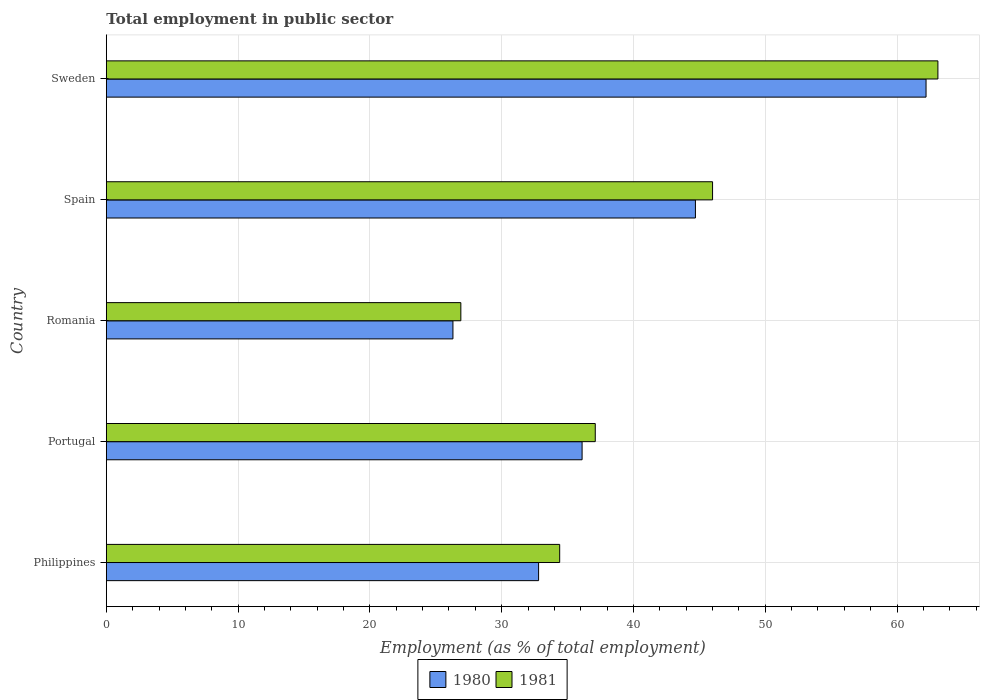How many groups of bars are there?
Ensure brevity in your answer.  5. Are the number of bars per tick equal to the number of legend labels?
Offer a very short reply. Yes. What is the label of the 3rd group of bars from the top?
Offer a terse response. Romania. What is the employment in public sector in 1980 in Romania?
Provide a short and direct response. 26.3. Across all countries, what is the maximum employment in public sector in 1981?
Offer a terse response. 63.1. Across all countries, what is the minimum employment in public sector in 1981?
Your response must be concise. 26.9. In which country was the employment in public sector in 1980 maximum?
Provide a short and direct response. Sweden. In which country was the employment in public sector in 1981 minimum?
Your answer should be very brief. Romania. What is the total employment in public sector in 1980 in the graph?
Your answer should be very brief. 202.1. What is the difference between the employment in public sector in 1980 in Philippines and that in Spain?
Provide a short and direct response. -11.9. What is the difference between the employment in public sector in 1980 in Spain and the employment in public sector in 1981 in Romania?
Your response must be concise. 17.8. What is the average employment in public sector in 1980 per country?
Ensure brevity in your answer.  40.42. What is the difference between the employment in public sector in 1981 and employment in public sector in 1980 in Spain?
Offer a terse response. 1.3. In how many countries, is the employment in public sector in 1980 greater than 40 %?
Ensure brevity in your answer.  2. What is the ratio of the employment in public sector in 1981 in Philippines to that in Portugal?
Offer a very short reply. 0.93. Is the employment in public sector in 1980 in Philippines less than that in Portugal?
Give a very brief answer. Yes. Is the difference between the employment in public sector in 1981 in Portugal and Spain greater than the difference between the employment in public sector in 1980 in Portugal and Spain?
Your response must be concise. No. What is the difference between the highest and the second highest employment in public sector in 1981?
Offer a terse response. 17.1. What is the difference between the highest and the lowest employment in public sector in 1980?
Your answer should be very brief. 35.9. In how many countries, is the employment in public sector in 1980 greater than the average employment in public sector in 1980 taken over all countries?
Make the answer very short. 2. What does the 2nd bar from the bottom in Philippines represents?
Provide a short and direct response. 1981. Are all the bars in the graph horizontal?
Ensure brevity in your answer.  Yes. How many countries are there in the graph?
Keep it short and to the point. 5. Are the values on the major ticks of X-axis written in scientific E-notation?
Give a very brief answer. No. Does the graph contain grids?
Keep it short and to the point. Yes. What is the title of the graph?
Offer a very short reply. Total employment in public sector. Does "1977" appear as one of the legend labels in the graph?
Your answer should be very brief. No. What is the label or title of the X-axis?
Keep it short and to the point. Employment (as % of total employment). What is the Employment (as % of total employment) of 1980 in Philippines?
Your response must be concise. 32.8. What is the Employment (as % of total employment) of 1981 in Philippines?
Give a very brief answer. 34.4. What is the Employment (as % of total employment) in 1980 in Portugal?
Make the answer very short. 36.1. What is the Employment (as % of total employment) in 1981 in Portugal?
Provide a succinct answer. 37.1. What is the Employment (as % of total employment) in 1980 in Romania?
Provide a succinct answer. 26.3. What is the Employment (as % of total employment) in 1981 in Romania?
Provide a short and direct response. 26.9. What is the Employment (as % of total employment) in 1980 in Spain?
Keep it short and to the point. 44.7. What is the Employment (as % of total employment) in 1981 in Spain?
Offer a terse response. 46. What is the Employment (as % of total employment) of 1980 in Sweden?
Keep it short and to the point. 62.2. What is the Employment (as % of total employment) of 1981 in Sweden?
Make the answer very short. 63.1. Across all countries, what is the maximum Employment (as % of total employment) of 1980?
Your answer should be very brief. 62.2. Across all countries, what is the maximum Employment (as % of total employment) in 1981?
Your answer should be compact. 63.1. Across all countries, what is the minimum Employment (as % of total employment) in 1980?
Provide a succinct answer. 26.3. Across all countries, what is the minimum Employment (as % of total employment) in 1981?
Offer a very short reply. 26.9. What is the total Employment (as % of total employment) in 1980 in the graph?
Offer a terse response. 202.1. What is the total Employment (as % of total employment) of 1981 in the graph?
Ensure brevity in your answer.  207.5. What is the difference between the Employment (as % of total employment) of 1980 in Philippines and that in Portugal?
Your answer should be very brief. -3.3. What is the difference between the Employment (as % of total employment) of 1981 in Philippines and that in Portugal?
Keep it short and to the point. -2.7. What is the difference between the Employment (as % of total employment) of 1980 in Philippines and that in Romania?
Provide a succinct answer. 6.5. What is the difference between the Employment (as % of total employment) of 1980 in Philippines and that in Sweden?
Provide a succinct answer. -29.4. What is the difference between the Employment (as % of total employment) in 1981 in Philippines and that in Sweden?
Provide a succinct answer. -28.7. What is the difference between the Employment (as % of total employment) of 1980 in Portugal and that in Romania?
Provide a short and direct response. 9.8. What is the difference between the Employment (as % of total employment) of 1980 in Portugal and that in Spain?
Keep it short and to the point. -8.6. What is the difference between the Employment (as % of total employment) in 1980 in Portugal and that in Sweden?
Your answer should be very brief. -26.1. What is the difference between the Employment (as % of total employment) of 1980 in Romania and that in Spain?
Give a very brief answer. -18.4. What is the difference between the Employment (as % of total employment) in 1981 in Romania and that in Spain?
Offer a terse response. -19.1. What is the difference between the Employment (as % of total employment) in 1980 in Romania and that in Sweden?
Offer a very short reply. -35.9. What is the difference between the Employment (as % of total employment) in 1981 in Romania and that in Sweden?
Offer a very short reply. -36.2. What is the difference between the Employment (as % of total employment) of 1980 in Spain and that in Sweden?
Keep it short and to the point. -17.5. What is the difference between the Employment (as % of total employment) in 1981 in Spain and that in Sweden?
Your answer should be compact. -17.1. What is the difference between the Employment (as % of total employment) of 1980 in Philippines and the Employment (as % of total employment) of 1981 in Romania?
Make the answer very short. 5.9. What is the difference between the Employment (as % of total employment) in 1980 in Philippines and the Employment (as % of total employment) in 1981 in Sweden?
Ensure brevity in your answer.  -30.3. What is the difference between the Employment (as % of total employment) of 1980 in Portugal and the Employment (as % of total employment) of 1981 in Romania?
Give a very brief answer. 9.2. What is the difference between the Employment (as % of total employment) in 1980 in Romania and the Employment (as % of total employment) in 1981 in Spain?
Your answer should be very brief. -19.7. What is the difference between the Employment (as % of total employment) of 1980 in Romania and the Employment (as % of total employment) of 1981 in Sweden?
Your response must be concise. -36.8. What is the difference between the Employment (as % of total employment) of 1980 in Spain and the Employment (as % of total employment) of 1981 in Sweden?
Offer a terse response. -18.4. What is the average Employment (as % of total employment) in 1980 per country?
Offer a very short reply. 40.42. What is the average Employment (as % of total employment) in 1981 per country?
Ensure brevity in your answer.  41.5. What is the difference between the Employment (as % of total employment) of 1980 and Employment (as % of total employment) of 1981 in Portugal?
Provide a short and direct response. -1. What is the difference between the Employment (as % of total employment) of 1980 and Employment (as % of total employment) of 1981 in Spain?
Give a very brief answer. -1.3. What is the ratio of the Employment (as % of total employment) of 1980 in Philippines to that in Portugal?
Give a very brief answer. 0.91. What is the ratio of the Employment (as % of total employment) of 1981 in Philippines to that in Portugal?
Give a very brief answer. 0.93. What is the ratio of the Employment (as % of total employment) of 1980 in Philippines to that in Romania?
Keep it short and to the point. 1.25. What is the ratio of the Employment (as % of total employment) in 1981 in Philippines to that in Romania?
Your answer should be very brief. 1.28. What is the ratio of the Employment (as % of total employment) in 1980 in Philippines to that in Spain?
Your response must be concise. 0.73. What is the ratio of the Employment (as % of total employment) in 1981 in Philippines to that in Spain?
Ensure brevity in your answer.  0.75. What is the ratio of the Employment (as % of total employment) of 1980 in Philippines to that in Sweden?
Make the answer very short. 0.53. What is the ratio of the Employment (as % of total employment) in 1981 in Philippines to that in Sweden?
Make the answer very short. 0.55. What is the ratio of the Employment (as % of total employment) of 1980 in Portugal to that in Romania?
Your answer should be compact. 1.37. What is the ratio of the Employment (as % of total employment) of 1981 in Portugal to that in Romania?
Ensure brevity in your answer.  1.38. What is the ratio of the Employment (as % of total employment) in 1980 in Portugal to that in Spain?
Your answer should be very brief. 0.81. What is the ratio of the Employment (as % of total employment) of 1981 in Portugal to that in Spain?
Give a very brief answer. 0.81. What is the ratio of the Employment (as % of total employment) of 1980 in Portugal to that in Sweden?
Provide a succinct answer. 0.58. What is the ratio of the Employment (as % of total employment) in 1981 in Portugal to that in Sweden?
Give a very brief answer. 0.59. What is the ratio of the Employment (as % of total employment) of 1980 in Romania to that in Spain?
Offer a very short reply. 0.59. What is the ratio of the Employment (as % of total employment) of 1981 in Romania to that in Spain?
Provide a succinct answer. 0.58. What is the ratio of the Employment (as % of total employment) of 1980 in Romania to that in Sweden?
Offer a very short reply. 0.42. What is the ratio of the Employment (as % of total employment) of 1981 in Romania to that in Sweden?
Your answer should be compact. 0.43. What is the ratio of the Employment (as % of total employment) in 1980 in Spain to that in Sweden?
Provide a succinct answer. 0.72. What is the ratio of the Employment (as % of total employment) of 1981 in Spain to that in Sweden?
Provide a short and direct response. 0.73. What is the difference between the highest and the lowest Employment (as % of total employment) of 1980?
Provide a short and direct response. 35.9. What is the difference between the highest and the lowest Employment (as % of total employment) of 1981?
Provide a succinct answer. 36.2. 